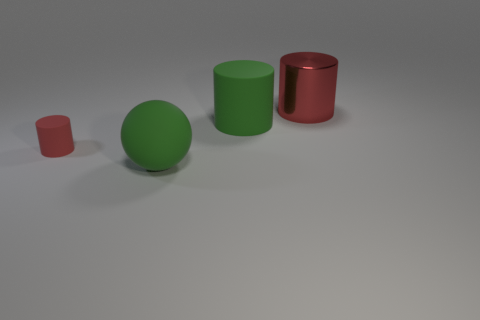Add 1 large rubber things. How many objects exist? 5 Subtract all cylinders. How many objects are left? 1 Add 2 big rubber things. How many big rubber things exist? 4 Subtract 0 brown spheres. How many objects are left? 4 Subtract all big balls. Subtract all green matte cylinders. How many objects are left? 2 Add 2 large green objects. How many large green objects are left? 4 